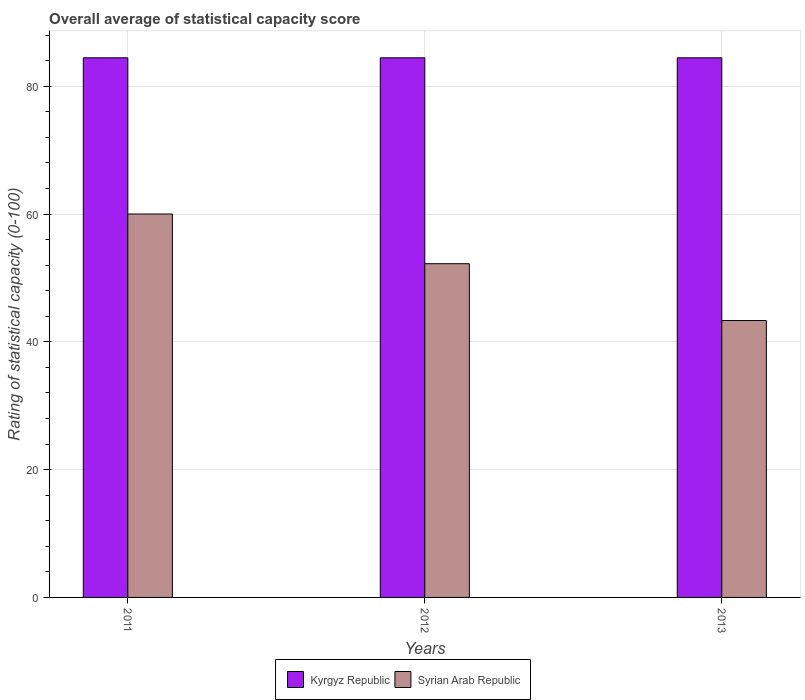How many different coloured bars are there?
Your response must be concise. 2. What is the label of the 3rd group of bars from the left?
Offer a very short reply. 2013. What is the rating of statistical capacity in Kyrgyz Republic in 2013?
Provide a short and direct response. 84.44. Across all years, what is the maximum rating of statistical capacity in Kyrgyz Republic?
Offer a terse response. 84.44. Across all years, what is the minimum rating of statistical capacity in Syrian Arab Republic?
Your response must be concise. 43.33. In which year was the rating of statistical capacity in Kyrgyz Republic minimum?
Offer a terse response. 2011. What is the total rating of statistical capacity in Syrian Arab Republic in the graph?
Provide a succinct answer. 155.56. What is the difference between the rating of statistical capacity in Syrian Arab Republic in 2011 and the rating of statistical capacity in Kyrgyz Republic in 2012?
Keep it short and to the point. -24.44. What is the average rating of statistical capacity in Syrian Arab Republic per year?
Provide a short and direct response. 51.85. In the year 2013, what is the difference between the rating of statistical capacity in Kyrgyz Republic and rating of statistical capacity in Syrian Arab Republic?
Your answer should be very brief. 41.11. In how many years, is the rating of statistical capacity in Syrian Arab Republic greater than 68?
Your response must be concise. 0. What is the ratio of the rating of statistical capacity in Syrian Arab Republic in 2011 to that in 2013?
Offer a terse response. 1.38. Is the rating of statistical capacity in Kyrgyz Republic in 2011 less than that in 2013?
Your answer should be very brief. No. Is the difference between the rating of statistical capacity in Kyrgyz Republic in 2011 and 2012 greater than the difference between the rating of statistical capacity in Syrian Arab Republic in 2011 and 2012?
Your response must be concise. No. What is the difference between the highest and the second highest rating of statistical capacity in Kyrgyz Republic?
Keep it short and to the point. 0. What is the difference between the highest and the lowest rating of statistical capacity in Syrian Arab Republic?
Provide a short and direct response. 16.67. In how many years, is the rating of statistical capacity in Kyrgyz Republic greater than the average rating of statistical capacity in Kyrgyz Republic taken over all years?
Your answer should be compact. 0. What does the 1st bar from the left in 2013 represents?
Offer a very short reply. Kyrgyz Republic. What does the 2nd bar from the right in 2013 represents?
Offer a very short reply. Kyrgyz Republic. How many bars are there?
Offer a very short reply. 6. How many years are there in the graph?
Keep it short and to the point. 3. What is the difference between two consecutive major ticks on the Y-axis?
Provide a succinct answer. 20. Are the values on the major ticks of Y-axis written in scientific E-notation?
Your answer should be compact. No. Does the graph contain grids?
Ensure brevity in your answer.  Yes. How are the legend labels stacked?
Make the answer very short. Horizontal. What is the title of the graph?
Give a very brief answer. Overall average of statistical capacity score. Does "Benin" appear as one of the legend labels in the graph?
Your response must be concise. No. What is the label or title of the Y-axis?
Give a very brief answer. Rating of statistical capacity (0-100). What is the Rating of statistical capacity (0-100) in Kyrgyz Republic in 2011?
Keep it short and to the point. 84.44. What is the Rating of statistical capacity (0-100) of Kyrgyz Republic in 2012?
Give a very brief answer. 84.44. What is the Rating of statistical capacity (0-100) in Syrian Arab Republic in 2012?
Your answer should be very brief. 52.22. What is the Rating of statistical capacity (0-100) in Kyrgyz Republic in 2013?
Offer a very short reply. 84.44. What is the Rating of statistical capacity (0-100) in Syrian Arab Republic in 2013?
Make the answer very short. 43.33. Across all years, what is the maximum Rating of statistical capacity (0-100) in Kyrgyz Republic?
Your answer should be very brief. 84.44. Across all years, what is the minimum Rating of statistical capacity (0-100) in Kyrgyz Republic?
Give a very brief answer. 84.44. Across all years, what is the minimum Rating of statistical capacity (0-100) of Syrian Arab Republic?
Ensure brevity in your answer.  43.33. What is the total Rating of statistical capacity (0-100) in Kyrgyz Republic in the graph?
Provide a succinct answer. 253.33. What is the total Rating of statistical capacity (0-100) in Syrian Arab Republic in the graph?
Ensure brevity in your answer.  155.56. What is the difference between the Rating of statistical capacity (0-100) of Kyrgyz Republic in 2011 and that in 2012?
Keep it short and to the point. 0. What is the difference between the Rating of statistical capacity (0-100) of Syrian Arab Republic in 2011 and that in 2012?
Your answer should be very brief. 7.78. What is the difference between the Rating of statistical capacity (0-100) of Syrian Arab Republic in 2011 and that in 2013?
Offer a terse response. 16.67. What is the difference between the Rating of statistical capacity (0-100) in Kyrgyz Republic in 2012 and that in 2013?
Make the answer very short. 0. What is the difference between the Rating of statistical capacity (0-100) in Syrian Arab Republic in 2012 and that in 2013?
Keep it short and to the point. 8.89. What is the difference between the Rating of statistical capacity (0-100) of Kyrgyz Republic in 2011 and the Rating of statistical capacity (0-100) of Syrian Arab Republic in 2012?
Offer a very short reply. 32.22. What is the difference between the Rating of statistical capacity (0-100) of Kyrgyz Republic in 2011 and the Rating of statistical capacity (0-100) of Syrian Arab Republic in 2013?
Give a very brief answer. 41.11. What is the difference between the Rating of statistical capacity (0-100) of Kyrgyz Republic in 2012 and the Rating of statistical capacity (0-100) of Syrian Arab Republic in 2013?
Ensure brevity in your answer.  41.11. What is the average Rating of statistical capacity (0-100) in Kyrgyz Republic per year?
Make the answer very short. 84.44. What is the average Rating of statistical capacity (0-100) in Syrian Arab Republic per year?
Your response must be concise. 51.85. In the year 2011, what is the difference between the Rating of statistical capacity (0-100) of Kyrgyz Republic and Rating of statistical capacity (0-100) of Syrian Arab Republic?
Provide a short and direct response. 24.44. In the year 2012, what is the difference between the Rating of statistical capacity (0-100) of Kyrgyz Republic and Rating of statistical capacity (0-100) of Syrian Arab Republic?
Your answer should be compact. 32.22. In the year 2013, what is the difference between the Rating of statistical capacity (0-100) in Kyrgyz Republic and Rating of statistical capacity (0-100) in Syrian Arab Republic?
Make the answer very short. 41.11. What is the ratio of the Rating of statistical capacity (0-100) of Kyrgyz Republic in 2011 to that in 2012?
Provide a short and direct response. 1. What is the ratio of the Rating of statistical capacity (0-100) in Syrian Arab Republic in 2011 to that in 2012?
Give a very brief answer. 1.15. What is the ratio of the Rating of statistical capacity (0-100) in Syrian Arab Republic in 2011 to that in 2013?
Make the answer very short. 1.38. What is the ratio of the Rating of statistical capacity (0-100) of Kyrgyz Republic in 2012 to that in 2013?
Provide a succinct answer. 1. What is the ratio of the Rating of statistical capacity (0-100) in Syrian Arab Republic in 2012 to that in 2013?
Provide a succinct answer. 1.21. What is the difference between the highest and the second highest Rating of statistical capacity (0-100) in Kyrgyz Republic?
Provide a short and direct response. 0. What is the difference between the highest and the second highest Rating of statistical capacity (0-100) of Syrian Arab Republic?
Your answer should be compact. 7.78. What is the difference between the highest and the lowest Rating of statistical capacity (0-100) in Syrian Arab Republic?
Provide a short and direct response. 16.67. 